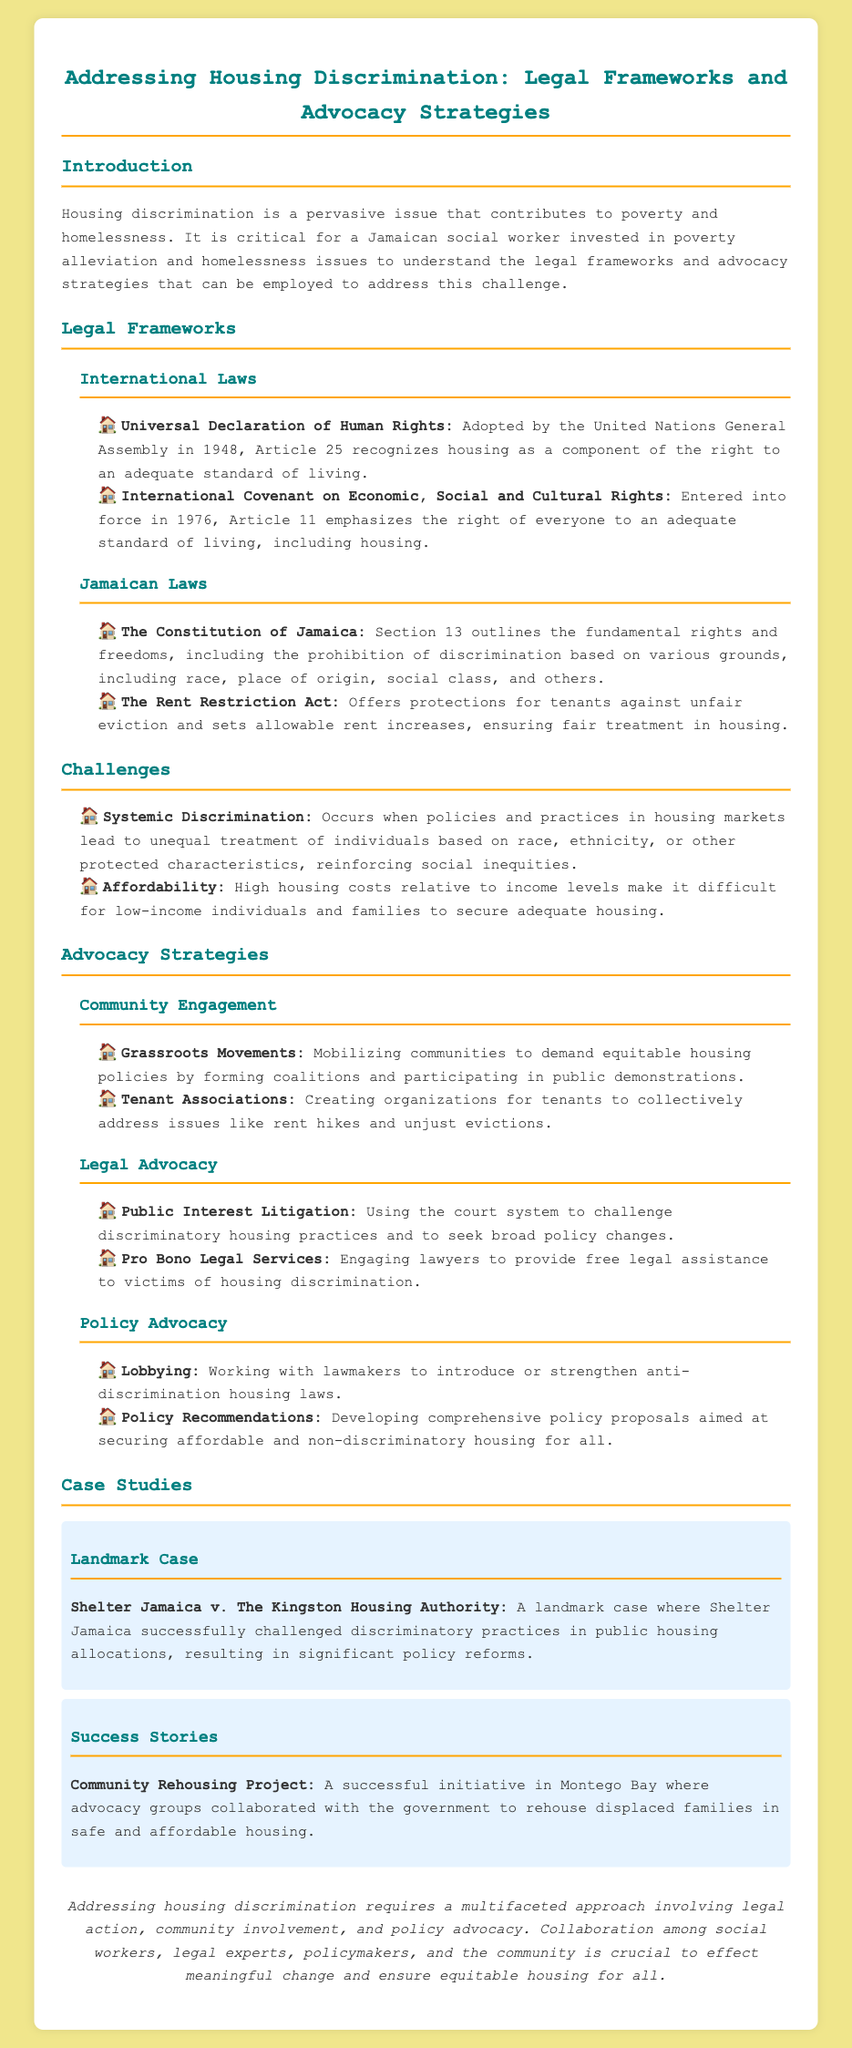What is the document's title? The title of the document is prominently stated at the top of the content, providing the main subject matter.
Answer: Addressing Housing Discrimination: Legal Frameworks and Advocacy Strategies What year was the Universal Declaration of Human Rights adopted? The document specifies that the Universal Declaration of Human Rights was adopted by the United Nations General Assembly in 1948.
Answer: 1948 What does Article 25 of the Universal Declaration of Human Rights recognize? The document mentions that Article 25 recognizes housing as a component of the right to an adequate standard of living.
Answer: Housing Which act offers protections for tenants against unfair eviction in Jamaica? The document lists the Rent Restriction Act, which is aimed at ensuring fair treatment in housing.
Answer: The Rent Restriction Act What is one challenge related to housing mentioned in the document? The document outlines challenges that contribute to housing discrimination, specifically detailing some key issues.
Answer: Affordability What type of advocacy strategy involves mobilizing communities? The document discusses various advocacy strategies, highlighting community engagement as a means of addressing housing issues.
Answer: Grassroots Movements Which landmark case is mentioned in the case studies? The document presents a specific case related to housing discrimination, noted as significant in promoting reforms.
Answer: Shelter Jamaica v. The Kingston Housing Authority What is a key conclusion of the document? The conclusion summarizes the document's primary messages about the need for a comprehensive approach to address housing discrimination.
Answer: Multifaceted approach 